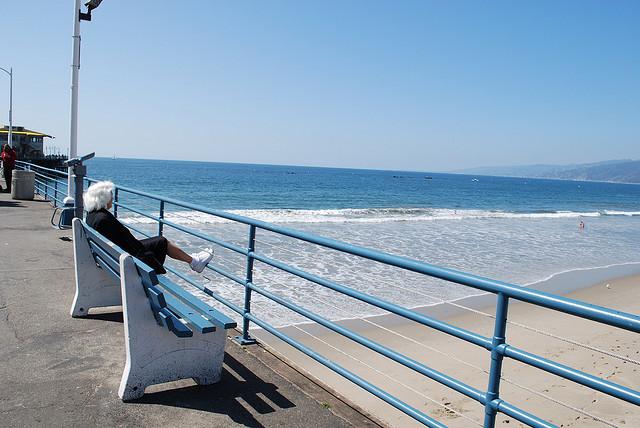How many benches are there?
Be succinct. 1. How many people have their head covered?
Quick response, please. 0. What color bench is she sitting on?
Keep it brief. Blue. Where is this?
Keep it brief. Beach. Where is the bench facing?
Be succinct. Beach. 